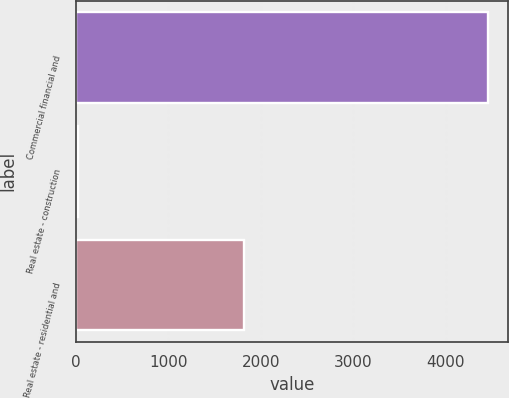<chart> <loc_0><loc_0><loc_500><loc_500><bar_chart><fcel>Commercial financial and<fcel>Real estate - construction<fcel>Real estate - residential and<nl><fcel>4453<fcel>25<fcel>1814<nl></chart> 